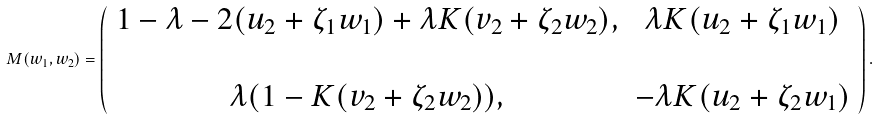Convert formula to latex. <formula><loc_0><loc_0><loc_500><loc_500>M ( w _ { 1 } , w _ { 2 } ) = \left ( \begin{array} { c c } 1 - \lambda - 2 ( u _ { 2 } + \zeta _ { 1 } w _ { 1 } ) + \lambda K ( v _ { 2 } + \zeta _ { 2 } w _ { 2 } ) , & \lambda K ( u _ { 2 } + \zeta _ { 1 } w _ { 1 } ) \\ \\ \lambda ( 1 - K ( v _ { 2 } + \zeta _ { 2 } w _ { 2 } ) ) , & - \lambda K ( u _ { 2 } + \zeta _ { 2 } w _ { 1 } ) \end{array} \right ) .</formula> 